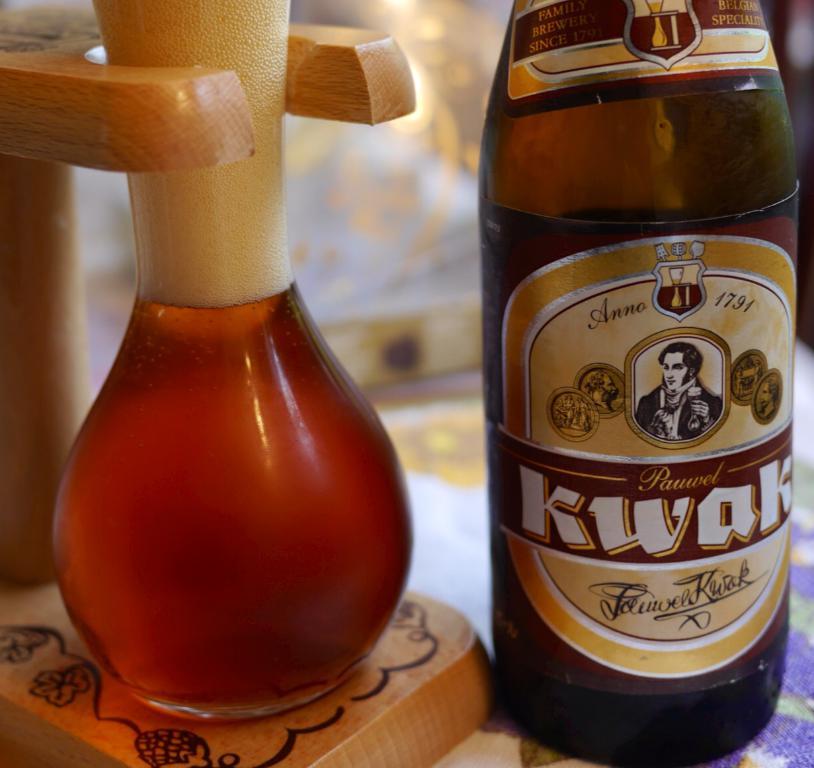What is the date printed near the top of the label?
Offer a very short reply. 1791. What is the name of the drink?
Give a very brief answer. Kwak. 